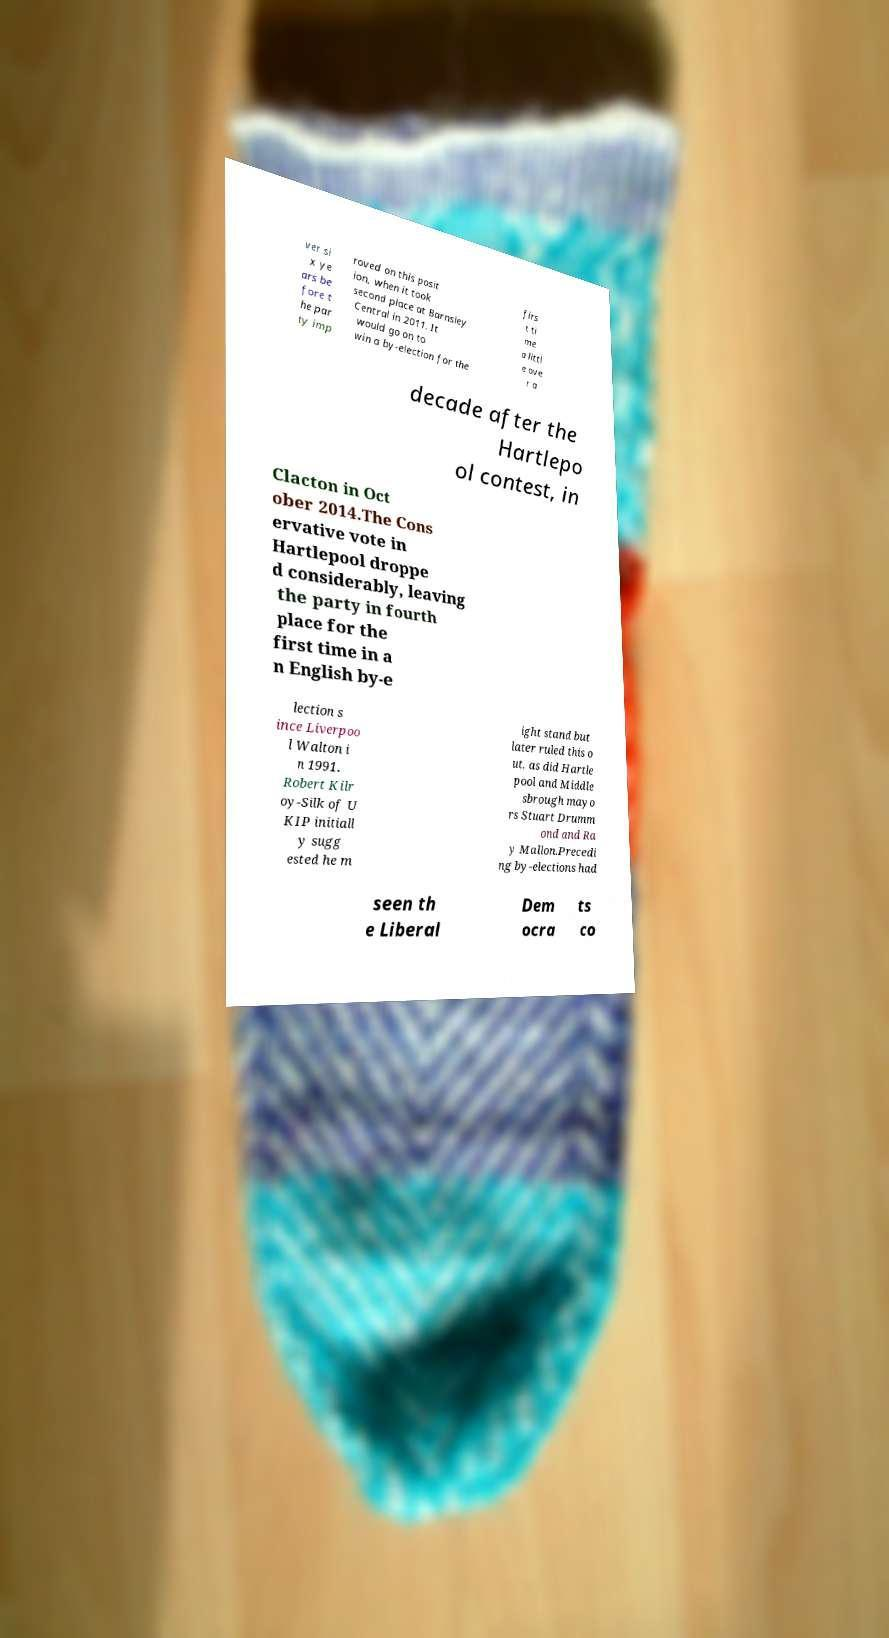Please identify and transcribe the text found in this image. ver si x ye ars be fore t he par ty imp roved on this posit ion, when it took second place at Barnsley Central in 2011. It would go on to win a by-election for the firs t ti me a littl e ove r a decade after the Hartlepo ol contest, in Clacton in Oct ober 2014.The Cons ervative vote in Hartlepool droppe d considerably, leaving the party in fourth place for the first time in a n English by-e lection s ince Liverpoo l Walton i n 1991. Robert Kilr oy-Silk of U KIP initiall y sugg ested he m ight stand but later ruled this o ut, as did Hartle pool and Middle sbrough mayo rs Stuart Drumm ond and Ra y Mallon.Precedi ng by-elections had seen th e Liberal Dem ocra ts co 